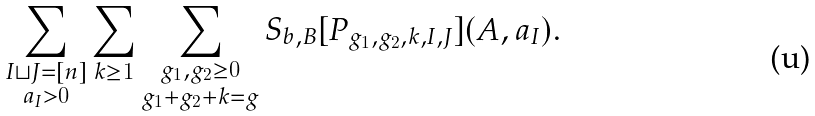Convert formula to latex. <formula><loc_0><loc_0><loc_500><loc_500>\sum _ { \substack { I \sqcup J = [ n ] \\ a _ { I } > 0 } } \sum _ { k \geq 1 } \sum _ { \substack { g _ { 1 } , g _ { 2 } \geq 0 \\ g _ { 1 } + g _ { 2 } + k = g } } S _ { b , B } [ P _ { g _ { 1 } , g _ { 2 } , k , I , J } ] ( A , a _ { I } ) .</formula> 